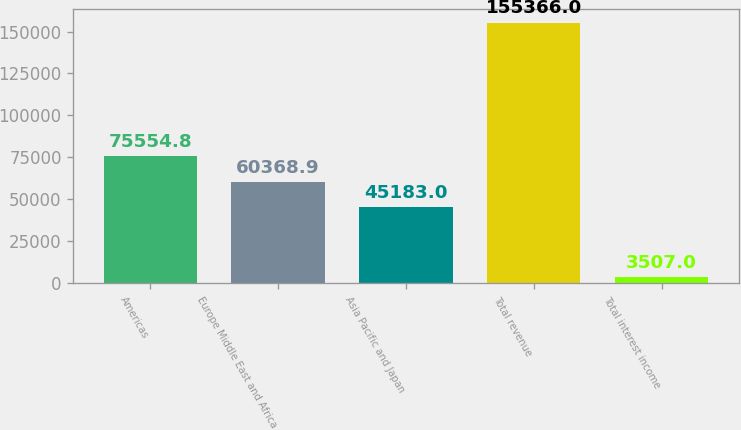<chart> <loc_0><loc_0><loc_500><loc_500><bar_chart><fcel>Americas<fcel>Europe Middle East and Africa<fcel>Asia Pacific and Japan<fcel>Total revenue<fcel>Total interest income<nl><fcel>75554.8<fcel>60368.9<fcel>45183<fcel>155366<fcel>3507<nl></chart> 